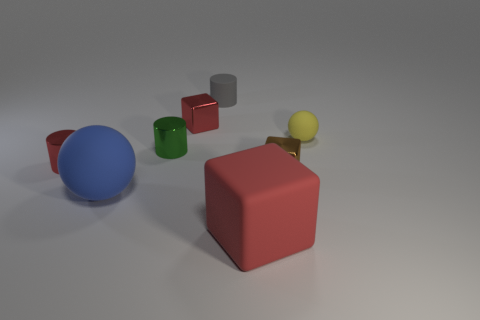Is there anything else that is the same material as the blue thing?
Your answer should be compact. Yes. What number of small objects are either gray rubber spheres or brown metal blocks?
Give a very brief answer. 1. Does the red metallic thing in front of the yellow thing have the same shape as the big red rubber object?
Make the answer very short. No. Are there fewer big gray things than tiny red metallic objects?
Your answer should be very brief. Yes. Is there anything else of the same color as the big ball?
Your answer should be very brief. No. What is the shape of the red metal object left of the small red metallic cube?
Ensure brevity in your answer.  Cylinder. There is a matte block; is its color the same as the large thing that is behind the big red matte object?
Keep it short and to the point. No. Is the number of brown shiny objects that are to the left of the green thing the same as the number of red shiny cylinders to the left of the tiny yellow rubber thing?
Your answer should be compact. No. How many other objects are the same size as the brown thing?
Offer a very short reply. 5. The yellow rubber thing is what size?
Make the answer very short. Small. 